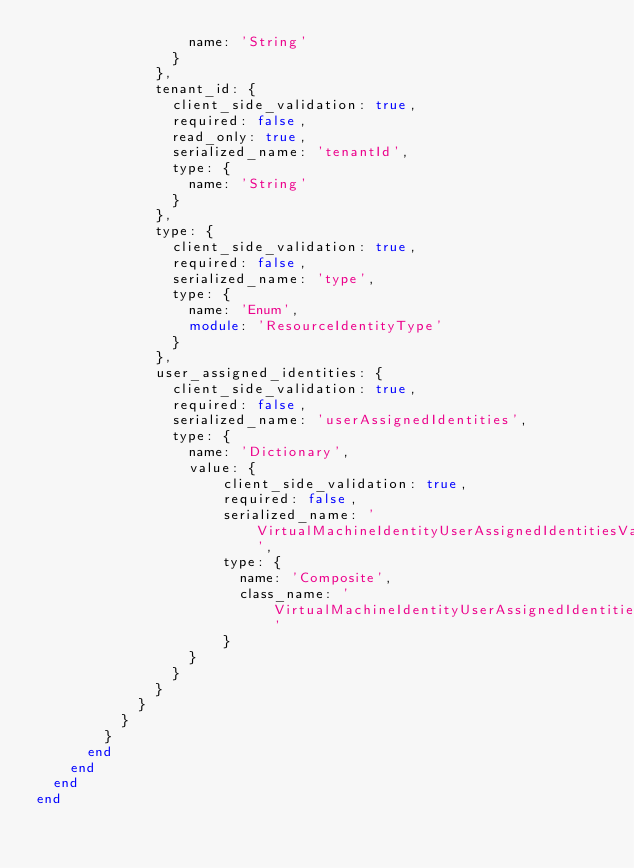Convert code to text. <code><loc_0><loc_0><loc_500><loc_500><_Ruby_>                  name: 'String'
                }
              },
              tenant_id: {
                client_side_validation: true,
                required: false,
                read_only: true,
                serialized_name: 'tenantId',
                type: {
                  name: 'String'
                }
              },
              type: {
                client_side_validation: true,
                required: false,
                serialized_name: 'type',
                type: {
                  name: 'Enum',
                  module: 'ResourceIdentityType'
                }
              },
              user_assigned_identities: {
                client_side_validation: true,
                required: false,
                serialized_name: 'userAssignedIdentities',
                type: {
                  name: 'Dictionary',
                  value: {
                      client_side_validation: true,
                      required: false,
                      serialized_name: 'VirtualMachineIdentityUserAssignedIdentitiesValueElementType',
                      type: {
                        name: 'Composite',
                        class_name: 'VirtualMachineIdentityUserAssignedIdentitiesValue'
                      }
                  }
                }
              }
            }
          }
        }
      end
    end
  end
end
</code> 